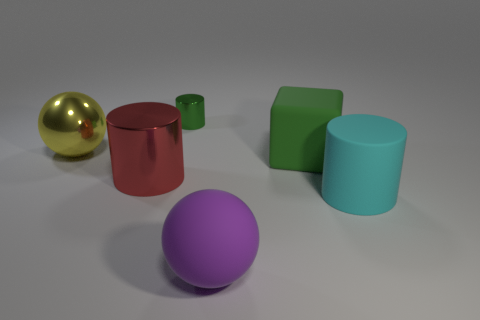Are there fewer small blue rubber cylinders than large purple balls?
Make the answer very short. Yes. Is the sphere in front of the big shiny sphere made of the same material as the cube?
Your answer should be compact. Yes. What number of cylinders are either large red objects or green things?
Provide a short and direct response. 2. What shape is the metallic thing that is behind the big green matte block and on the right side of the large yellow shiny ball?
Your answer should be compact. Cylinder. There is a big metallic thing behind the large metallic thing that is right of the large sphere behind the rubber sphere; what color is it?
Provide a succinct answer. Yellow. Are there fewer green objects to the left of the purple matte object than large purple metallic things?
Offer a very short reply. No. There is a metal thing that is left of the large shiny cylinder; does it have the same shape as the large metal object that is to the right of the large yellow ball?
Ensure brevity in your answer.  No. What number of things are either objects that are on the left side of the large cyan thing or metal cylinders?
Provide a short and direct response. 5. There is a thing that is the same color as the small cylinder; what material is it?
Offer a very short reply. Rubber. There is a green thing that is on the left side of the matte sphere right of the red cylinder; is there a yellow shiny object that is to the left of it?
Your answer should be compact. Yes. 